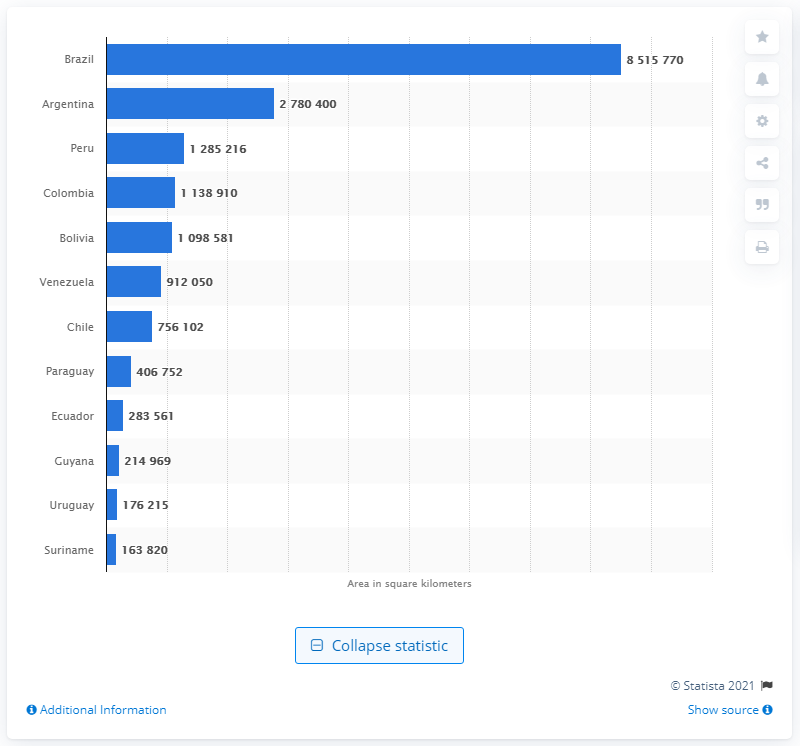List a handful of essential elements in this visual. Brazil is the largest country in South America. Argentina has a total area of approximately 2780400 square kilometers. 